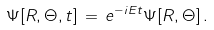Convert formula to latex. <formula><loc_0><loc_0><loc_500><loc_500>\Psi [ R , \Theta , t ] \, = \, e ^ { - i E t } \Psi [ R , \Theta ] \, .</formula> 